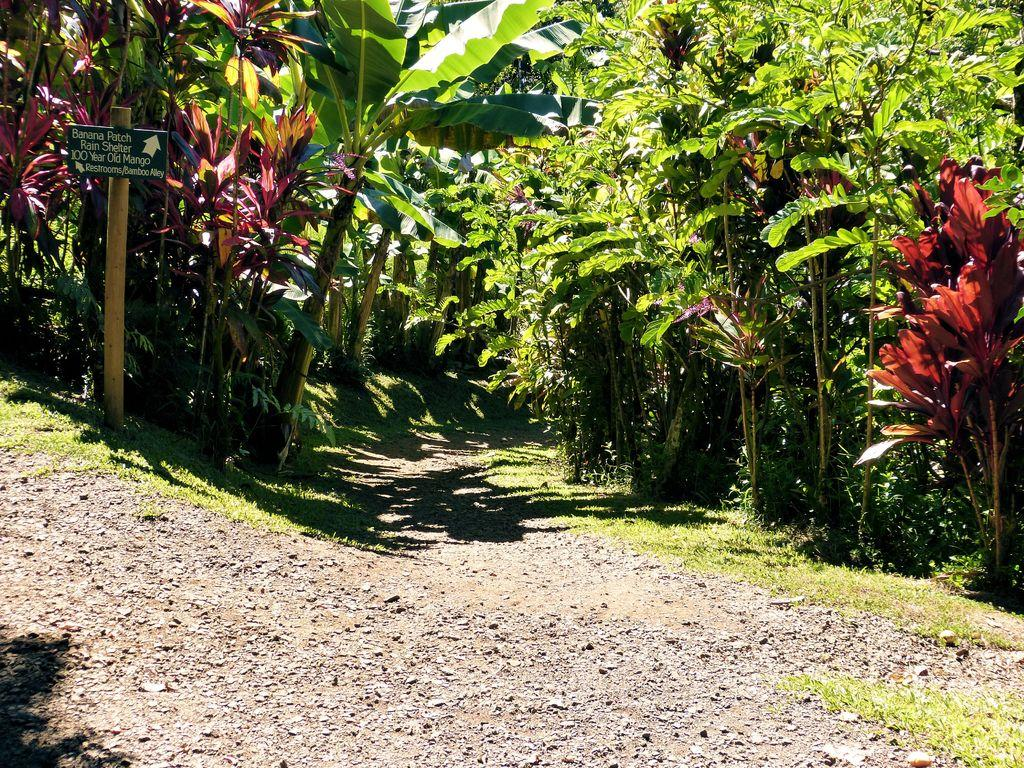What is located on the left side of the image? There is a board on the left side of the image. What can be seen in the middle of the image? There are trees in the middle of the image. What type of ground is visible at the bottom of the image? Soil is visible at the bottom of the image. Can you tell me how many berries are on the woman's hat in the image? There is no woman or hat present in the image, so it is not possible to answer that question. 